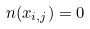Convert formula to latex. <formula><loc_0><loc_0><loc_500><loc_500>n ( x _ { i , j } ) = 0</formula> 